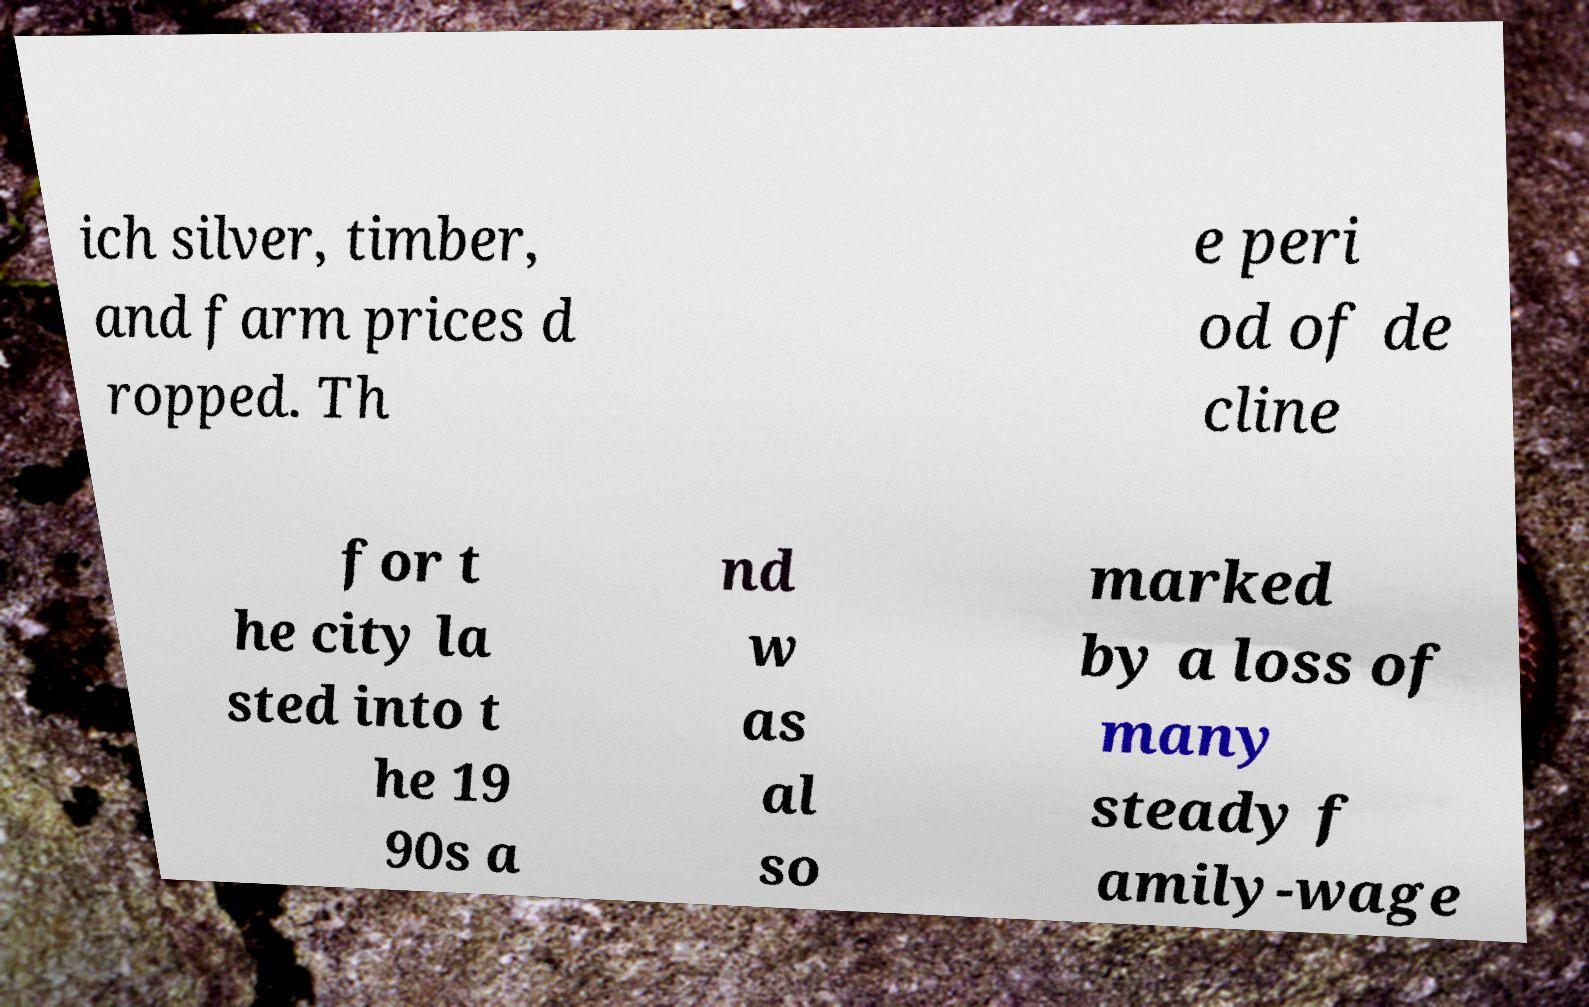I need the written content from this picture converted into text. Can you do that? ich silver, timber, and farm prices d ropped. Th e peri od of de cline for t he city la sted into t he 19 90s a nd w as al so marked by a loss of many steady f amily-wage 